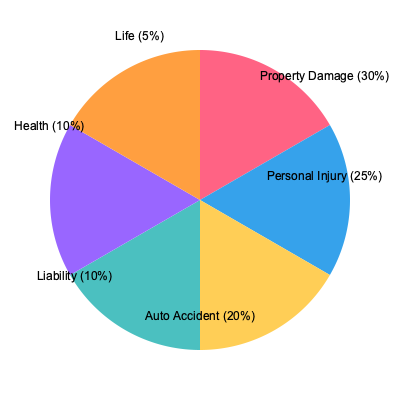Based on the pie chart showing the distribution of insurance claim types, what percentage of claims are related to personal injury and auto accidents combined? To solve this problem, we need to follow these steps:

1. Identify the percentages for personal injury and auto accident claims from the pie chart:
   - Personal Injury: 25%
   - Auto Accident: 20%

2. Add these two percentages together:
   $25\% + 20\% = 45\%$

Therefore, the combined percentage of claims related to personal injury and auto accidents is 45%.

This question relates to the persona of an academic researcher studying the impact of machine learning on insurance risk analysis because understanding the distribution of claim types is crucial for developing and applying machine learning models in risk assessment and pricing strategies for insurance companies.
Answer: 45% 